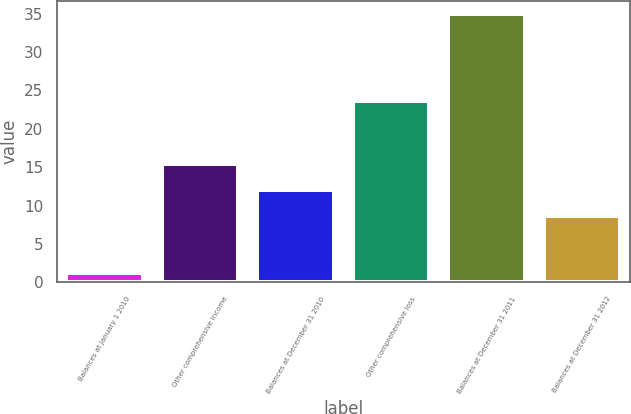Convert chart. <chart><loc_0><loc_0><loc_500><loc_500><bar_chart><fcel>Balances at January 1 2010<fcel>Other comprehensive income<fcel>Balances at December 31 2010<fcel>Other comprehensive loss<fcel>Balances at December 31 2011<fcel>Balances at December 31 2012<nl><fcel>1.2<fcel>15.44<fcel>12.07<fcel>23.6<fcel>34.9<fcel>8.7<nl></chart> 